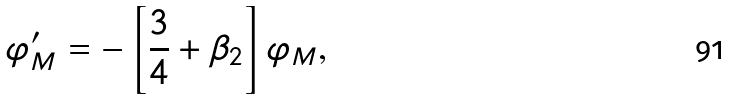<formula> <loc_0><loc_0><loc_500><loc_500>\varphi ^ { \prime } _ { M } = - \left [ \frac { 3 } { 4 } + \beta _ { 2 } \right ] \varphi _ { M } ,</formula> 